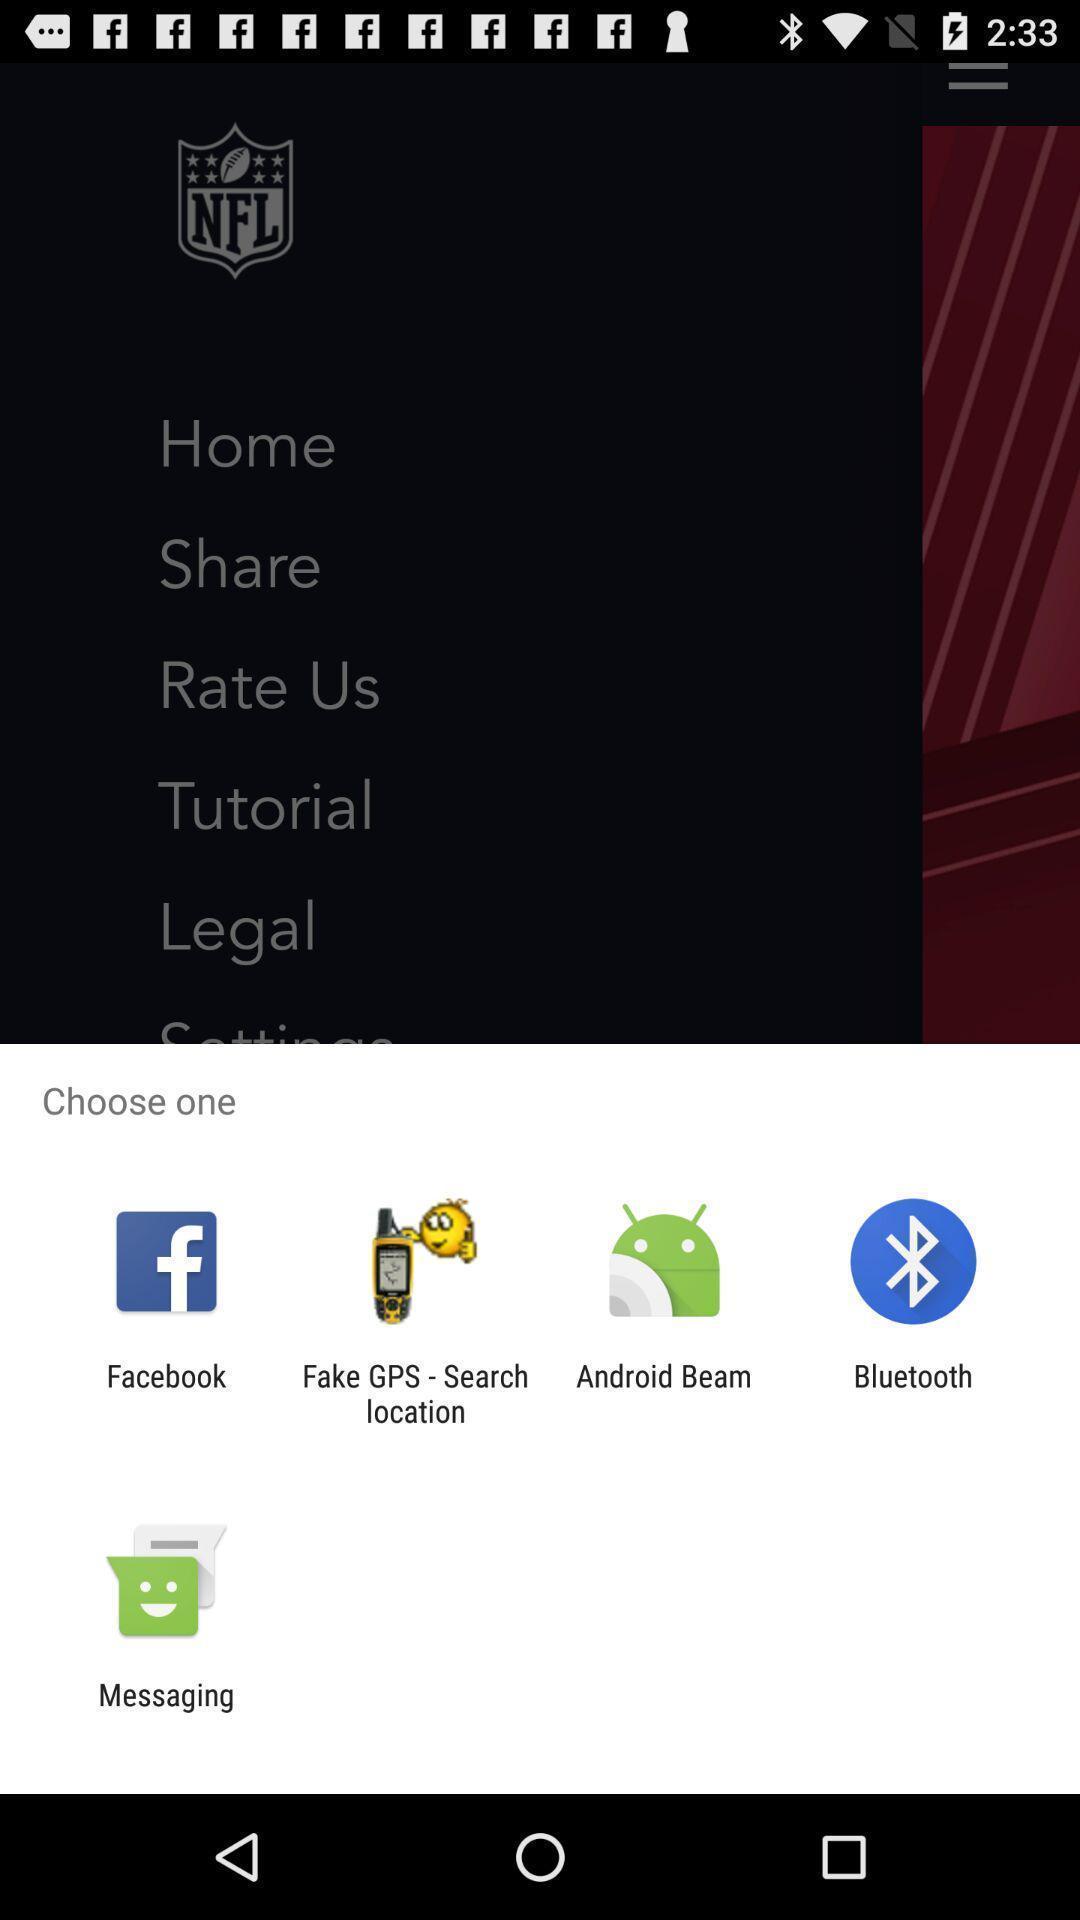Explain what's happening in this screen capture. Pop-up to choose an app. 